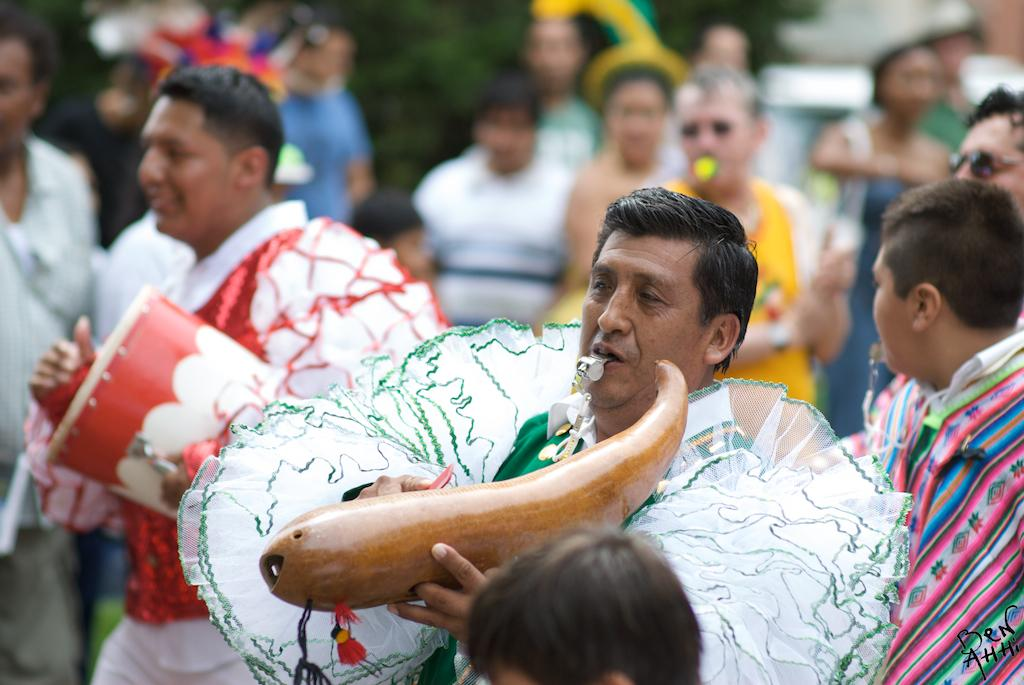What are the people in the image doing? The people in the image are playing musical instruments. What can be seen in the background of the image? There are trees visible in the background of the image. What flavor of mark can be seen on the trees in the image? There is no mark or flavor mentioned in the image; it only features people playing musical instruments and trees in the background. 